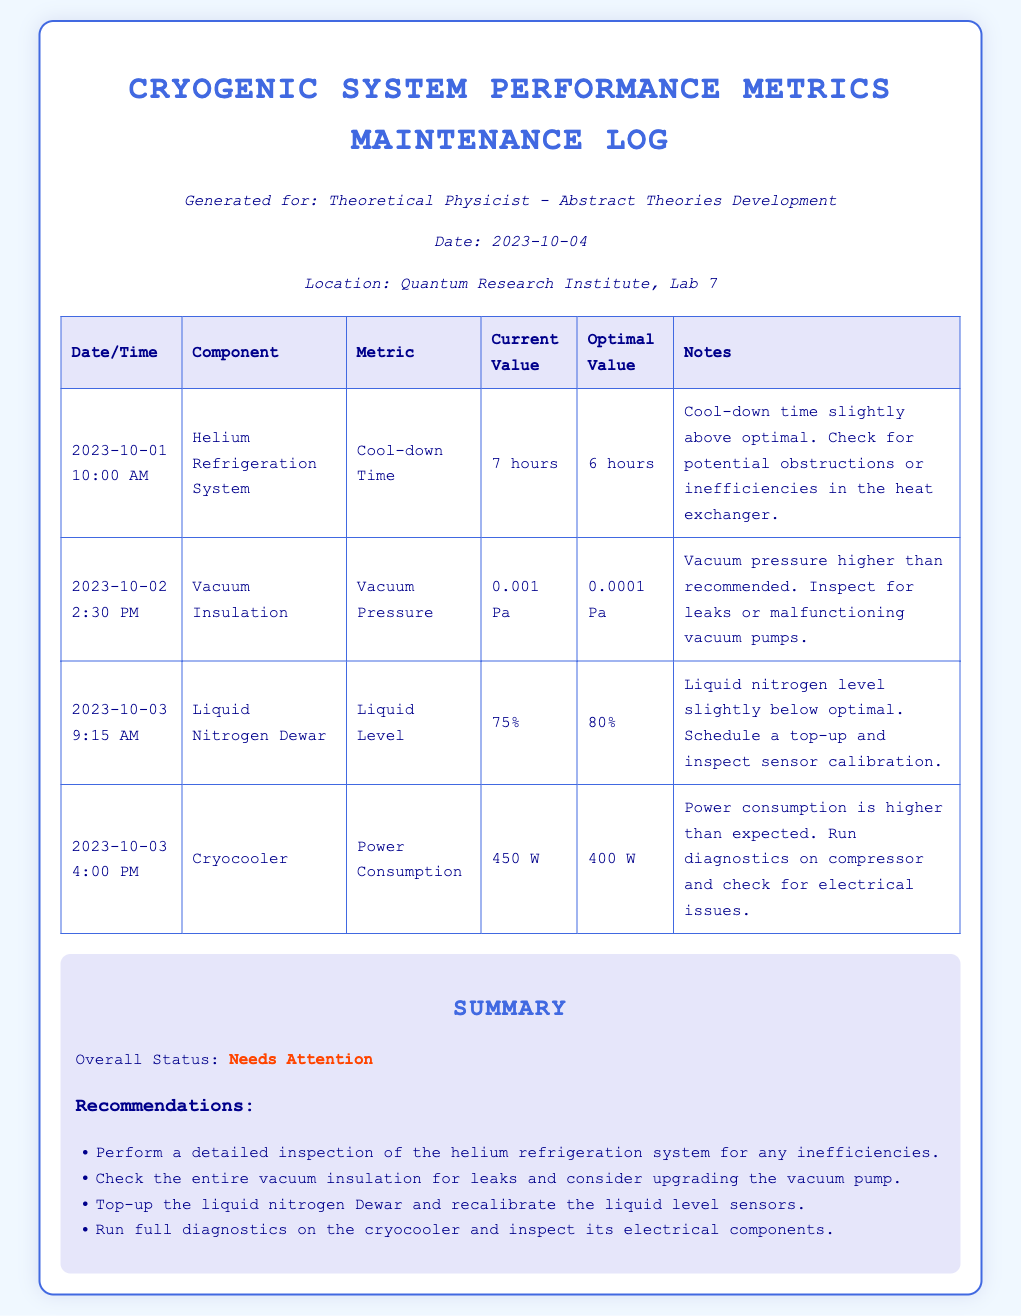What is the cool-down time of the Helium Refrigeration System? The cool-down time of the Helium Refrigeration System is specified in the log as 7 hours, which is mentioned under the current value metric.
Answer: 7 hours What is the vacuum pressure recorded on October 2nd? The vacuum pressure recorded on October 2nd, 2:30 PM, is indicated as 0.001 Pa in the log.
Answer: 0.001 Pa What is the optimal value for liquid nitrogen level? The optimal value for the liquid nitrogen level is stated to be 80% in the maintenance log.
Answer: 80% What was the power consumption of the Cryocooler on October 3rd? The power consumption of the Cryocooler on October 3rd, 4:00 PM, is shown in the log as 450 W.
Answer: 450 W What issue is noted regarding the vacuum insulation? The issue noted regarding the vacuum insulation is that the vacuum pressure is higher than recommended, requiring inspection for leaks or malfunctioning pumps.
Answer: Higher than recommended What is the overall status of the Cryogenic System? The overall status of the Cryogenic System is described as "Needs Attention" as summarized at the end of the log.
Answer: Needs Attention How many recommendations are given in the summary? The summary section of the maintenance log includes a total of four recommendations for addressing the noted issues.
Answer: Four What component requires inspection for electrical issues? The component that requires inspection for electrical issues is the Cryocooler, as indicated in the notes section of the related entry.
Answer: Cryocooler 